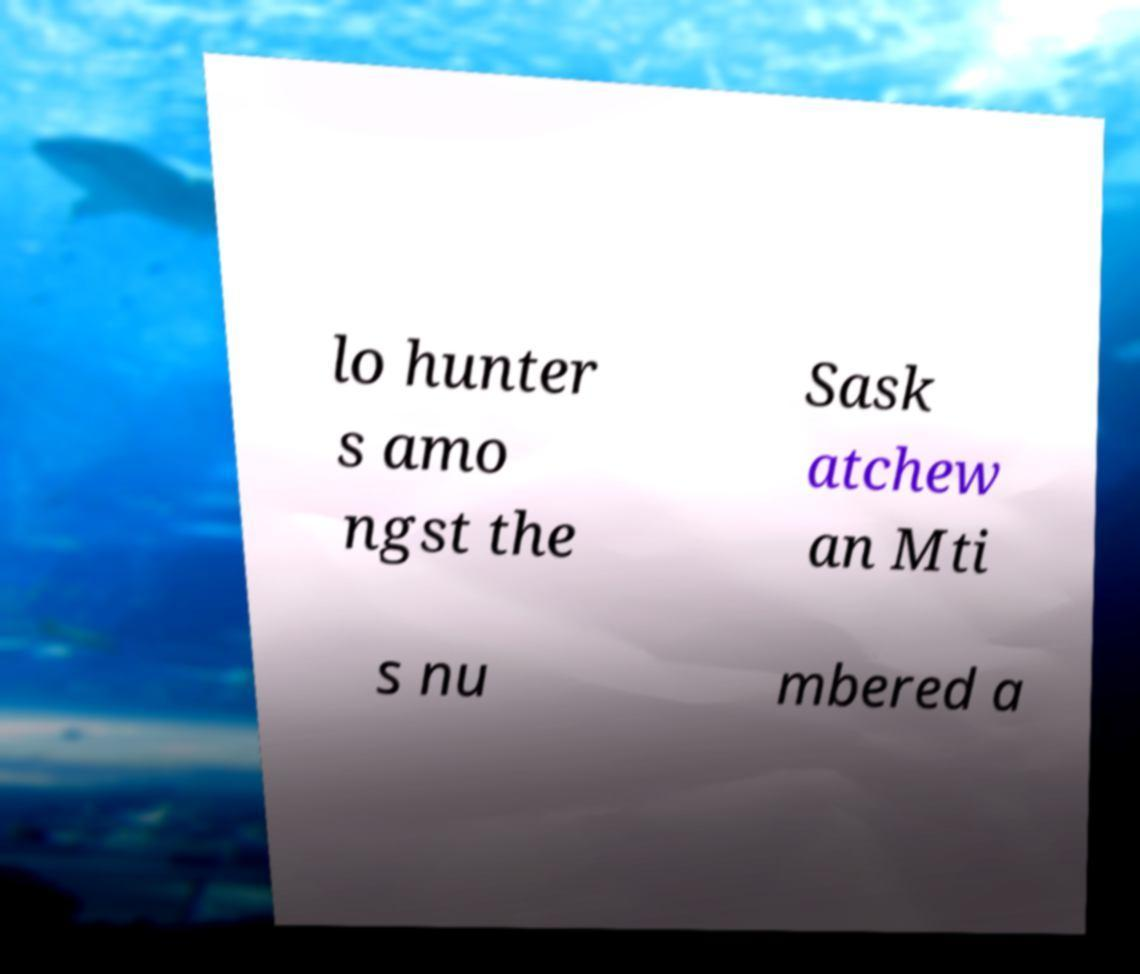Please identify and transcribe the text found in this image. lo hunter s amo ngst the Sask atchew an Mti s nu mbered a 